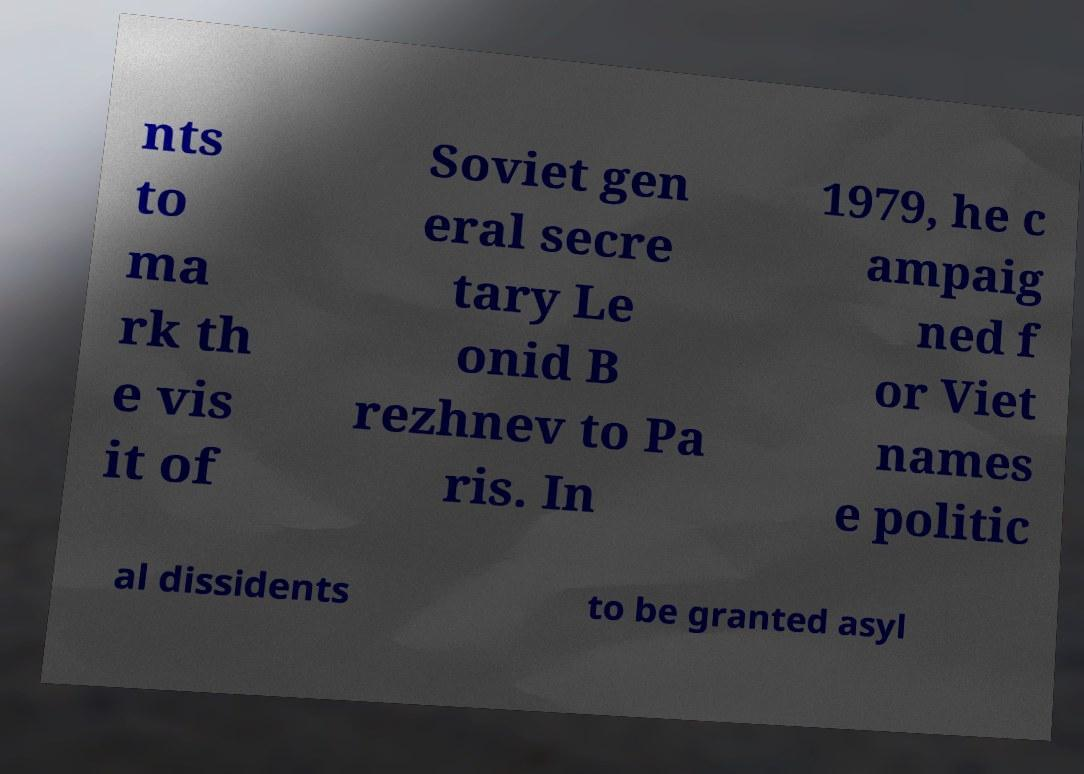Could you extract and type out the text from this image? nts to ma rk th e vis it of Soviet gen eral secre tary Le onid B rezhnev to Pa ris. In 1979, he c ampaig ned f or Viet names e politic al dissidents to be granted asyl 